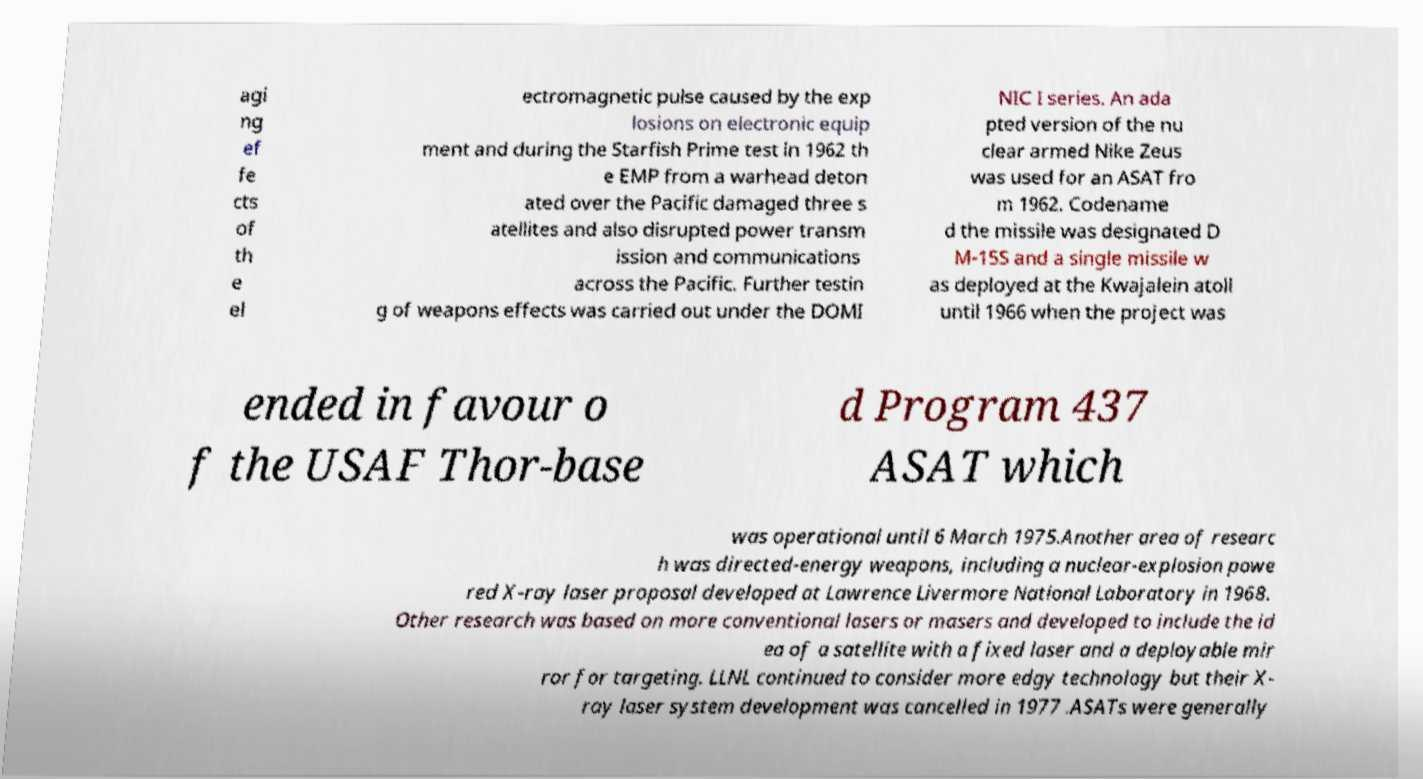Please read and relay the text visible in this image. What does it say? agi ng ef fe cts of th e el ectromagnetic pulse caused by the exp losions on electronic equip ment and during the Starfish Prime test in 1962 th e EMP from a warhead deton ated over the Pacific damaged three s atellites and also disrupted power transm ission and communications across the Pacific. Further testin g of weapons effects was carried out under the DOMI NIC I series. An ada pted version of the nu clear armed Nike Zeus was used for an ASAT fro m 1962. Codename d the missile was designated D M-15S and a single missile w as deployed at the Kwajalein atoll until 1966 when the project was ended in favour o f the USAF Thor-base d Program 437 ASAT which was operational until 6 March 1975.Another area of researc h was directed-energy weapons, including a nuclear-explosion powe red X-ray laser proposal developed at Lawrence Livermore National Laboratory in 1968. Other research was based on more conventional lasers or masers and developed to include the id ea of a satellite with a fixed laser and a deployable mir ror for targeting. LLNL continued to consider more edgy technology but their X- ray laser system development was cancelled in 1977 .ASATs were generally 